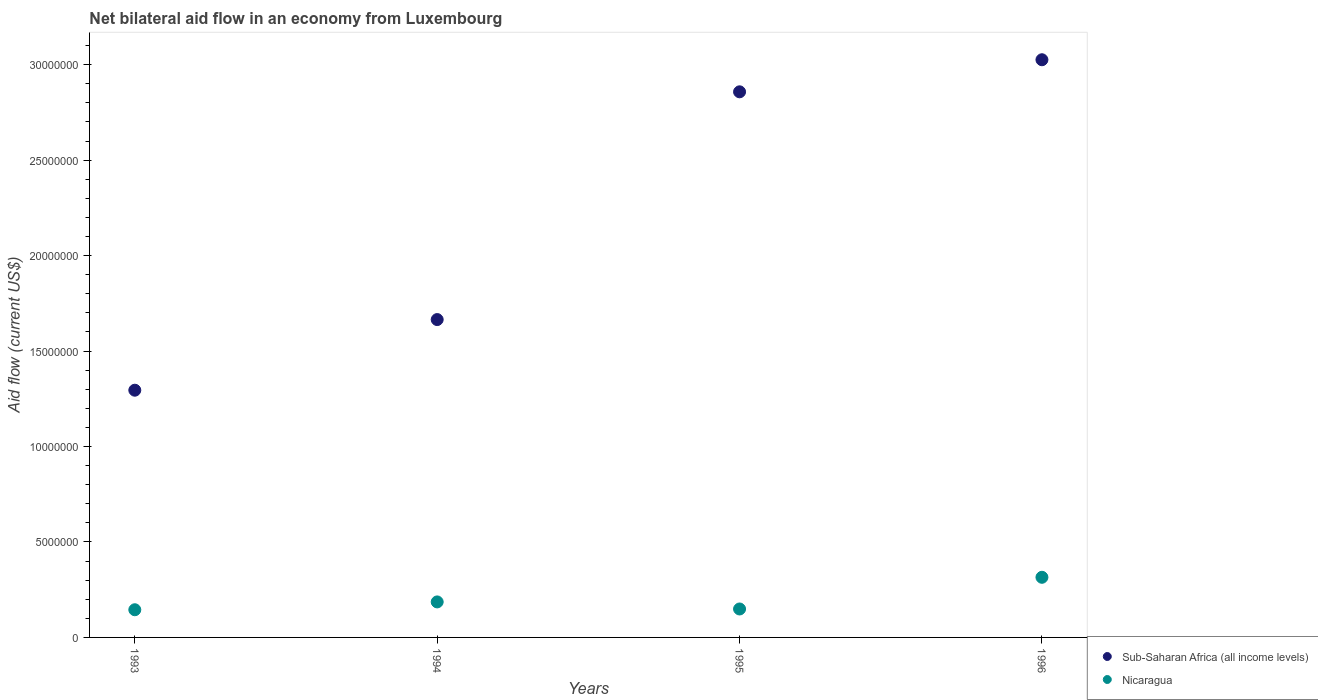Is the number of dotlines equal to the number of legend labels?
Keep it short and to the point. Yes. What is the net bilateral aid flow in Sub-Saharan Africa (all income levels) in 1995?
Offer a terse response. 2.86e+07. Across all years, what is the maximum net bilateral aid flow in Sub-Saharan Africa (all income levels)?
Offer a terse response. 3.03e+07. Across all years, what is the minimum net bilateral aid flow in Sub-Saharan Africa (all income levels)?
Provide a succinct answer. 1.30e+07. In which year was the net bilateral aid flow in Nicaragua maximum?
Ensure brevity in your answer.  1996. In which year was the net bilateral aid flow in Sub-Saharan Africa (all income levels) minimum?
Keep it short and to the point. 1993. What is the total net bilateral aid flow in Nicaragua in the graph?
Offer a very short reply. 7.95e+06. What is the difference between the net bilateral aid flow in Nicaragua in 1993 and that in 1994?
Your answer should be compact. -4.10e+05. What is the difference between the net bilateral aid flow in Sub-Saharan Africa (all income levels) in 1994 and the net bilateral aid flow in Nicaragua in 1996?
Keep it short and to the point. 1.35e+07. What is the average net bilateral aid flow in Nicaragua per year?
Make the answer very short. 1.99e+06. In the year 1995, what is the difference between the net bilateral aid flow in Nicaragua and net bilateral aid flow in Sub-Saharan Africa (all income levels)?
Your answer should be very brief. -2.71e+07. In how many years, is the net bilateral aid flow in Nicaragua greater than 9000000 US$?
Make the answer very short. 0. What is the ratio of the net bilateral aid flow in Nicaragua in 1995 to that in 1996?
Make the answer very short. 0.47. Is the difference between the net bilateral aid flow in Nicaragua in 1994 and 1995 greater than the difference between the net bilateral aid flow in Sub-Saharan Africa (all income levels) in 1994 and 1995?
Offer a terse response. Yes. What is the difference between the highest and the second highest net bilateral aid flow in Nicaragua?
Keep it short and to the point. 1.29e+06. What is the difference between the highest and the lowest net bilateral aid flow in Sub-Saharan Africa (all income levels)?
Provide a short and direct response. 1.73e+07. In how many years, is the net bilateral aid flow in Nicaragua greater than the average net bilateral aid flow in Nicaragua taken over all years?
Give a very brief answer. 1. Does the net bilateral aid flow in Sub-Saharan Africa (all income levels) monotonically increase over the years?
Your response must be concise. Yes. Is the net bilateral aid flow in Nicaragua strictly less than the net bilateral aid flow in Sub-Saharan Africa (all income levels) over the years?
Your response must be concise. Yes. How many dotlines are there?
Your answer should be compact. 2. How many years are there in the graph?
Keep it short and to the point. 4. Does the graph contain any zero values?
Offer a very short reply. No. How are the legend labels stacked?
Keep it short and to the point. Vertical. What is the title of the graph?
Your answer should be compact. Net bilateral aid flow in an economy from Luxembourg. Does "Monaco" appear as one of the legend labels in the graph?
Offer a terse response. No. What is the label or title of the X-axis?
Keep it short and to the point. Years. What is the Aid flow (current US$) of Sub-Saharan Africa (all income levels) in 1993?
Ensure brevity in your answer.  1.30e+07. What is the Aid flow (current US$) in Nicaragua in 1993?
Make the answer very short. 1.45e+06. What is the Aid flow (current US$) of Sub-Saharan Africa (all income levels) in 1994?
Keep it short and to the point. 1.66e+07. What is the Aid flow (current US$) of Nicaragua in 1994?
Offer a very short reply. 1.86e+06. What is the Aid flow (current US$) in Sub-Saharan Africa (all income levels) in 1995?
Give a very brief answer. 2.86e+07. What is the Aid flow (current US$) in Nicaragua in 1995?
Your answer should be very brief. 1.49e+06. What is the Aid flow (current US$) in Sub-Saharan Africa (all income levels) in 1996?
Provide a short and direct response. 3.03e+07. What is the Aid flow (current US$) in Nicaragua in 1996?
Provide a short and direct response. 3.15e+06. Across all years, what is the maximum Aid flow (current US$) of Sub-Saharan Africa (all income levels)?
Keep it short and to the point. 3.03e+07. Across all years, what is the maximum Aid flow (current US$) in Nicaragua?
Make the answer very short. 3.15e+06. Across all years, what is the minimum Aid flow (current US$) in Sub-Saharan Africa (all income levels)?
Provide a short and direct response. 1.30e+07. Across all years, what is the minimum Aid flow (current US$) of Nicaragua?
Make the answer very short. 1.45e+06. What is the total Aid flow (current US$) of Sub-Saharan Africa (all income levels) in the graph?
Give a very brief answer. 8.84e+07. What is the total Aid flow (current US$) of Nicaragua in the graph?
Keep it short and to the point. 7.95e+06. What is the difference between the Aid flow (current US$) of Sub-Saharan Africa (all income levels) in 1993 and that in 1994?
Provide a short and direct response. -3.70e+06. What is the difference between the Aid flow (current US$) in Nicaragua in 1993 and that in 1994?
Offer a terse response. -4.10e+05. What is the difference between the Aid flow (current US$) of Sub-Saharan Africa (all income levels) in 1993 and that in 1995?
Ensure brevity in your answer.  -1.56e+07. What is the difference between the Aid flow (current US$) of Nicaragua in 1993 and that in 1995?
Offer a very short reply. -4.00e+04. What is the difference between the Aid flow (current US$) of Sub-Saharan Africa (all income levels) in 1993 and that in 1996?
Give a very brief answer. -1.73e+07. What is the difference between the Aid flow (current US$) of Nicaragua in 1993 and that in 1996?
Offer a terse response. -1.70e+06. What is the difference between the Aid flow (current US$) in Sub-Saharan Africa (all income levels) in 1994 and that in 1995?
Ensure brevity in your answer.  -1.19e+07. What is the difference between the Aid flow (current US$) of Sub-Saharan Africa (all income levels) in 1994 and that in 1996?
Keep it short and to the point. -1.36e+07. What is the difference between the Aid flow (current US$) in Nicaragua in 1994 and that in 1996?
Your answer should be very brief. -1.29e+06. What is the difference between the Aid flow (current US$) in Sub-Saharan Africa (all income levels) in 1995 and that in 1996?
Provide a short and direct response. -1.68e+06. What is the difference between the Aid flow (current US$) in Nicaragua in 1995 and that in 1996?
Your answer should be compact. -1.66e+06. What is the difference between the Aid flow (current US$) in Sub-Saharan Africa (all income levels) in 1993 and the Aid flow (current US$) in Nicaragua in 1994?
Ensure brevity in your answer.  1.11e+07. What is the difference between the Aid flow (current US$) of Sub-Saharan Africa (all income levels) in 1993 and the Aid flow (current US$) of Nicaragua in 1995?
Provide a succinct answer. 1.15e+07. What is the difference between the Aid flow (current US$) of Sub-Saharan Africa (all income levels) in 1993 and the Aid flow (current US$) of Nicaragua in 1996?
Provide a succinct answer. 9.80e+06. What is the difference between the Aid flow (current US$) of Sub-Saharan Africa (all income levels) in 1994 and the Aid flow (current US$) of Nicaragua in 1995?
Your answer should be compact. 1.52e+07. What is the difference between the Aid flow (current US$) of Sub-Saharan Africa (all income levels) in 1994 and the Aid flow (current US$) of Nicaragua in 1996?
Ensure brevity in your answer.  1.35e+07. What is the difference between the Aid flow (current US$) in Sub-Saharan Africa (all income levels) in 1995 and the Aid flow (current US$) in Nicaragua in 1996?
Offer a terse response. 2.54e+07. What is the average Aid flow (current US$) in Sub-Saharan Africa (all income levels) per year?
Keep it short and to the point. 2.21e+07. What is the average Aid flow (current US$) of Nicaragua per year?
Provide a succinct answer. 1.99e+06. In the year 1993, what is the difference between the Aid flow (current US$) in Sub-Saharan Africa (all income levels) and Aid flow (current US$) in Nicaragua?
Make the answer very short. 1.15e+07. In the year 1994, what is the difference between the Aid flow (current US$) of Sub-Saharan Africa (all income levels) and Aid flow (current US$) of Nicaragua?
Your answer should be very brief. 1.48e+07. In the year 1995, what is the difference between the Aid flow (current US$) of Sub-Saharan Africa (all income levels) and Aid flow (current US$) of Nicaragua?
Keep it short and to the point. 2.71e+07. In the year 1996, what is the difference between the Aid flow (current US$) in Sub-Saharan Africa (all income levels) and Aid flow (current US$) in Nicaragua?
Your answer should be very brief. 2.71e+07. What is the ratio of the Aid flow (current US$) in Sub-Saharan Africa (all income levels) in 1993 to that in 1994?
Your answer should be compact. 0.78. What is the ratio of the Aid flow (current US$) of Nicaragua in 1993 to that in 1994?
Keep it short and to the point. 0.78. What is the ratio of the Aid flow (current US$) of Sub-Saharan Africa (all income levels) in 1993 to that in 1995?
Give a very brief answer. 0.45. What is the ratio of the Aid flow (current US$) in Nicaragua in 1993 to that in 1995?
Ensure brevity in your answer.  0.97. What is the ratio of the Aid flow (current US$) of Sub-Saharan Africa (all income levels) in 1993 to that in 1996?
Give a very brief answer. 0.43. What is the ratio of the Aid flow (current US$) in Nicaragua in 1993 to that in 1996?
Make the answer very short. 0.46. What is the ratio of the Aid flow (current US$) of Sub-Saharan Africa (all income levels) in 1994 to that in 1995?
Offer a terse response. 0.58. What is the ratio of the Aid flow (current US$) of Nicaragua in 1994 to that in 1995?
Your response must be concise. 1.25. What is the ratio of the Aid flow (current US$) in Sub-Saharan Africa (all income levels) in 1994 to that in 1996?
Your answer should be compact. 0.55. What is the ratio of the Aid flow (current US$) of Nicaragua in 1994 to that in 1996?
Offer a terse response. 0.59. What is the ratio of the Aid flow (current US$) of Sub-Saharan Africa (all income levels) in 1995 to that in 1996?
Make the answer very short. 0.94. What is the ratio of the Aid flow (current US$) in Nicaragua in 1995 to that in 1996?
Provide a succinct answer. 0.47. What is the difference between the highest and the second highest Aid flow (current US$) in Sub-Saharan Africa (all income levels)?
Provide a succinct answer. 1.68e+06. What is the difference between the highest and the second highest Aid flow (current US$) in Nicaragua?
Keep it short and to the point. 1.29e+06. What is the difference between the highest and the lowest Aid flow (current US$) in Sub-Saharan Africa (all income levels)?
Provide a short and direct response. 1.73e+07. What is the difference between the highest and the lowest Aid flow (current US$) in Nicaragua?
Your answer should be compact. 1.70e+06. 